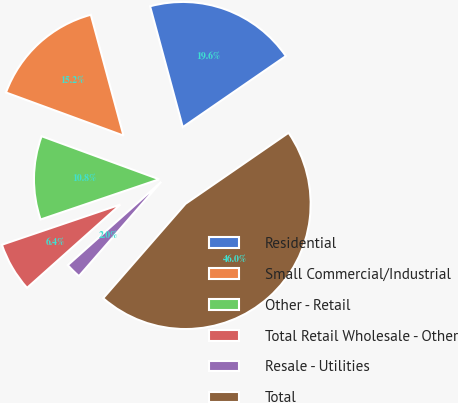Convert chart to OTSL. <chart><loc_0><loc_0><loc_500><loc_500><pie_chart><fcel>Residential<fcel>Small Commercial/Industrial<fcel>Other - Retail<fcel>Total Retail Wholesale - Other<fcel>Resale - Utilities<fcel>Total<nl><fcel>19.6%<fcel>15.2%<fcel>10.8%<fcel>6.39%<fcel>1.99%<fcel>46.02%<nl></chart> 